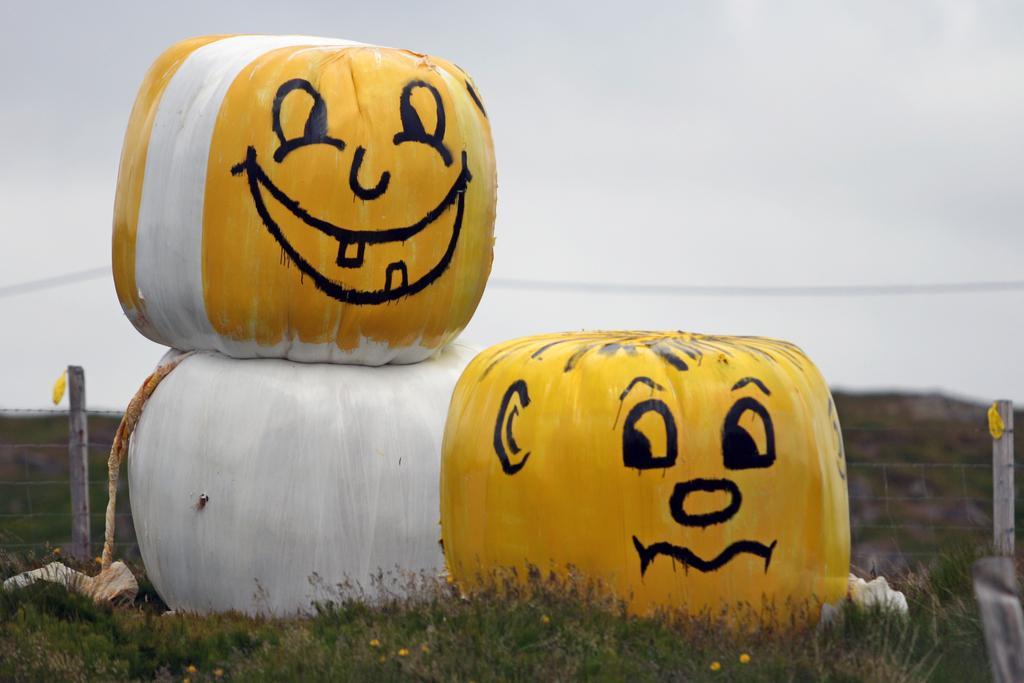Describe this image in one or two sentences. In this image there are three pumpkins on the grass, which are painted with yellow, white and black colors , and in the background there is wire fence, sky. 